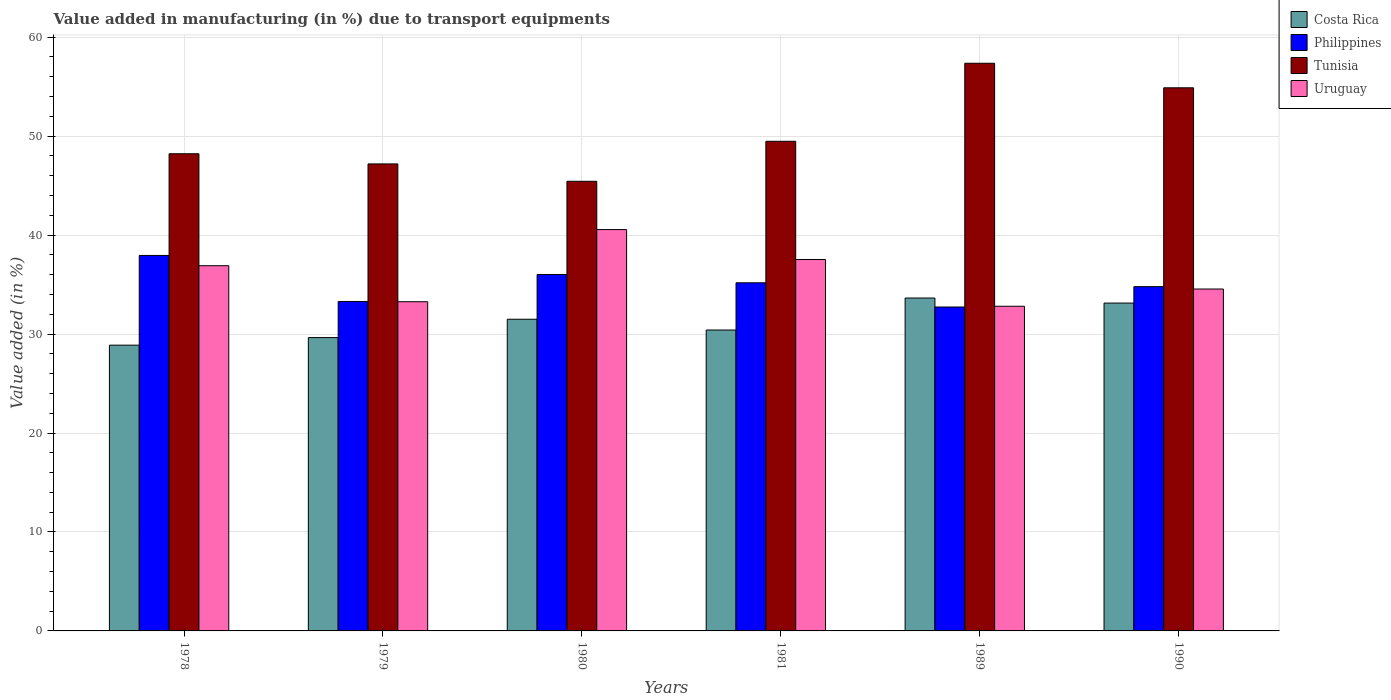How many bars are there on the 4th tick from the left?
Your answer should be compact. 4. How many bars are there on the 5th tick from the right?
Your answer should be compact. 4. What is the percentage of value added in manufacturing due to transport equipments in Philippines in 1981?
Your answer should be very brief. 35.18. Across all years, what is the maximum percentage of value added in manufacturing due to transport equipments in Uruguay?
Your answer should be compact. 40.56. Across all years, what is the minimum percentage of value added in manufacturing due to transport equipments in Uruguay?
Give a very brief answer. 32.81. In which year was the percentage of value added in manufacturing due to transport equipments in Uruguay minimum?
Keep it short and to the point. 1989. What is the total percentage of value added in manufacturing due to transport equipments in Uruguay in the graph?
Offer a terse response. 215.62. What is the difference between the percentage of value added in manufacturing due to transport equipments in Philippines in 1978 and that in 1990?
Keep it short and to the point. 3.15. What is the difference between the percentage of value added in manufacturing due to transport equipments in Philippines in 1981 and the percentage of value added in manufacturing due to transport equipments in Uruguay in 1989?
Keep it short and to the point. 2.37. What is the average percentage of value added in manufacturing due to transport equipments in Tunisia per year?
Keep it short and to the point. 50.43. In the year 1990, what is the difference between the percentage of value added in manufacturing due to transport equipments in Costa Rica and percentage of value added in manufacturing due to transport equipments in Tunisia?
Offer a terse response. -21.75. In how many years, is the percentage of value added in manufacturing due to transport equipments in Philippines greater than 6 %?
Make the answer very short. 6. What is the ratio of the percentage of value added in manufacturing due to transport equipments in Philippines in 1978 to that in 1981?
Your answer should be very brief. 1.08. Is the difference between the percentage of value added in manufacturing due to transport equipments in Costa Rica in 1980 and 1990 greater than the difference between the percentage of value added in manufacturing due to transport equipments in Tunisia in 1980 and 1990?
Provide a short and direct response. Yes. What is the difference between the highest and the second highest percentage of value added in manufacturing due to transport equipments in Uruguay?
Give a very brief answer. 3.03. What is the difference between the highest and the lowest percentage of value added in manufacturing due to transport equipments in Tunisia?
Make the answer very short. 11.93. In how many years, is the percentage of value added in manufacturing due to transport equipments in Uruguay greater than the average percentage of value added in manufacturing due to transport equipments in Uruguay taken over all years?
Keep it short and to the point. 3. Is the sum of the percentage of value added in manufacturing due to transport equipments in Costa Rica in 1981 and 1989 greater than the maximum percentage of value added in manufacturing due to transport equipments in Tunisia across all years?
Provide a short and direct response. Yes. What does the 3rd bar from the left in 1981 represents?
Give a very brief answer. Tunisia. Is it the case that in every year, the sum of the percentage of value added in manufacturing due to transport equipments in Philippines and percentage of value added in manufacturing due to transport equipments in Costa Rica is greater than the percentage of value added in manufacturing due to transport equipments in Tunisia?
Ensure brevity in your answer.  Yes. Are all the bars in the graph horizontal?
Offer a very short reply. No. What is the difference between two consecutive major ticks on the Y-axis?
Give a very brief answer. 10. Does the graph contain any zero values?
Offer a very short reply. No. Where does the legend appear in the graph?
Offer a terse response. Top right. How many legend labels are there?
Offer a terse response. 4. What is the title of the graph?
Keep it short and to the point. Value added in manufacturing (in %) due to transport equipments. Does "Bosnia and Herzegovina" appear as one of the legend labels in the graph?
Provide a short and direct response. No. What is the label or title of the X-axis?
Provide a short and direct response. Years. What is the label or title of the Y-axis?
Offer a terse response. Value added (in %). What is the Value added (in %) of Costa Rica in 1978?
Ensure brevity in your answer.  28.88. What is the Value added (in %) of Philippines in 1978?
Keep it short and to the point. 37.94. What is the Value added (in %) in Tunisia in 1978?
Provide a succinct answer. 48.22. What is the Value added (in %) in Uruguay in 1978?
Provide a short and direct response. 36.91. What is the Value added (in %) in Costa Rica in 1979?
Your answer should be compact. 29.64. What is the Value added (in %) of Philippines in 1979?
Provide a succinct answer. 33.29. What is the Value added (in %) in Tunisia in 1979?
Offer a very short reply. 47.19. What is the Value added (in %) of Uruguay in 1979?
Your answer should be compact. 33.27. What is the Value added (in %) of Costa Rica in 1980?
Give a very brief answer. 31.5. What is the Value added (in %) of Philippines in 1980?
Make the answer very short. 36.02. What is the Value added (in %) in Tunisia in 1980?
Ensure brevity in your answer.  45.44. What is the Value added (in %) of Uruguay in 1980?
Keep it short and to the point. 40.56. What is the Value added (in %) of Costa Rica in 1981?
Keep it short and to the point. 30.41. What is the Value added (in %) of Philippines in 1981?
Give a very brief answer. 35.18. What is the Value added (in %) in Tunisia in 1981?
Offer a very short reply. 49.48. What is the Value added (in %) of Uruguay in 1981?
Your answer should be compact. 37.53. What is the Value added (in %) in Costa Rica in 1989?
Ensure brevity in your answer.  33.64. What is the Value added (in %) in Philippines in 1989?
Your answer should be compact. 32.73. What is the Value added (in %) of Tunisia in 1989?
Make the answer very short. 57.36. What is the Value added (in %) of Uruguay in 1989?
Offer a terse response. 32.81. What is the Value added (in %) in Costa Rica in 1990?
Give a very brief answer. 33.13. What is the Value added (in %) of Philippines in 1990?
Provide a short and direct response. 34.79. What is the Value added (in %) in Tunisia in 1990?
Your answer should be very brief. 54.88. What is the Value added (in %) in Uruguay in 1990?
Your answer should be very brief. 34.55. Across all years, what is the maximum Value added (in %) in Costa Rica?
Your answer should be compact. 33.64. Across all years, what is the maximum Value added (in %) of Philippines?
Make the answer very short. 37.94. Across all years, what is the maximum Value added (in %) in Tunisia?
Offer a very short reply. 57.36. Across all years, what is the maximum Value added (in %) in Uruguay?
Give a very brief answer. 40.56. Across all years, what is the minimum Value added (in %) in Costa Rica?
Your response must be concise. 28.88. Across all years, what is the minimum Value added (in %) of Philippines?
Your response must be concise. 32.73. Across all years, what is the minimum Value added (in %) in Tunisia?
Offer a very short reply. 45.44. Across all years, what is the minimum Value added (in %) of Uruguay?
Your answer should be compact. 32.81. What is the total Value added (in %) of Costa Rica in the graph?
Ensure brevity in your answer.  187.19. What is the total Value added (in %) of Philippines in the graph?
Ensure brevity in your answer.  209.95. What is the total Value added (in %) of Tunisia in the graph?
Your response must be concise. 302.57. What is the total Value added (in %) in Uruguay in the graph?
Make the answer very short. 215.62. What is the difference between the Value added (in %) of Costa Rica in 1978 and that in 1979?
Give a very brief answer. -0.77. What is the difference between the Value added (in %) of Philippines in 1978 and that in 1979?
Offer a very short reply. 4.65. What is the difference between the Value added (in %) of Uruguay in 1978 and that in 1979?
Ensure brevity in your answer.  3.64. What is the difference between the Value added (in %) in Costa Rica in 1978 and that in 1980?
Your answer should be very brief. -2.62. What is the difference between the Value added (in %) of Philippines in 1978 and that in 1980?
Your response must be concise. 1.93. What is the difference between the Value added (in %) in Tunisia in 1978 and that in 1980?
Provide a short and direct response. 2.78. What is the difference between the Value added (in %) in Uruguay in 1978 and that in 1980?
Your response must be concise. -3.65. What is the difference between the Value added (in %) in Costa Rica in 1978 and that in 1981?
Offer a terse response. -1.53. What is the difference between the Value added (in %) in Philippines in 1978 and that in 1981?
Give a very brief answer. 2.76. What is the difference between the Value added (in %) in Tunisia in 1978 and that in 1981?
Keep it short and to the point. -1.26. What is the difference between the Value added (in %) of Uruguay in 1978 and that in 1981?
Ensure brevity in your answer.  -0.63. What is the difference between the Value added (in %) of Costa Rica in 1978 and that in 1989?
Give a very brief answer. -4.76. What is the difference between the Value added (in %) in Philippines in 1978 and that in 1989?
Your answer should be very brief. 5.21. What is the difference between the Value added (in %) in Tunisia in 1978 and that in 1989?
Ensure brevity in your answer.  -9.14. What is the difference between the Value added (in %) of Uruguay in 1978 and that in 1989?
Provide a short and direct response. 4.1. What is the difference between the Value added (in %) of Costa Rica in 1978 and that in 1990?
Provide a succinct answer. -4.25. What is the difference between the Value added (in %) of Philippines in 1978 and that in 1990?
Ensure brevity in your answer.  3.15. What is the difference between the Value added (in %) of Tunisia in 1978 and that in 1990?
Offer a very short reply. -6.66. What is the difference between the Value added (in %) of Uruguay in 1978 and that in 1990?
Provide a succinct answer. 2.36. What is the difference between the Value added (in %) in Costa Rica in 1979 and that in 1980?
Make the answer very short. -1.85. What is the difference between the Value added (in %) in Philippines in 1979 and that in 1980?
Provide a short and direct response. -2.73. What is the difference between the Value added (in %) in Tunisia in 1979 and that in 1980?
Your answer should be very brief. 1.76. What is the difference between the Value added (in %) in Uruguay in 1979 and that in 1980?
Your response must be concise. -7.29. What is the difference between the Value added (in %) of Costa Rica in 1979 and that in 1981?
Your answer should be compact. -0.76. What is the difference between the Value added (in %) in Philippines in 1979 and that in 1981?
Your answer should be compact. -1.89. What is the difference between the Value added (in %) of Tunisia in 1979 and that in 1981?
Provide a short and direct response. -2.29. What is the difference between the Value added (in %) of Uruguay in 1979 and that in 1981?
Offer a very short reply. -4.27. What is the difference between the Value added (in %) in Costa Rica in 1979 and that in 1989?
Make the answer very short. -4. What is the difference between the Value added (in %) of Philippines in 1979 and that in 1989?
Keep it short and to the point. 0.56. What is the difference between the Value added (in %) in Tunisia in 1979 and that in 1989?
Provide a short and direct response. -10.17. What is the difference between the Value added (in %) in Uruguay in 1979 and that in 1989?
Provide a short and direct response. 0.46. What is the difference between the Value added (in %) of Costa Rica in 1979 and that in 1990?
Provide a short and direct response. -3.49. What is the difference between the Value added (in %) in Philippines in 1979 and that in 1990?
Offer a terse response. -1.5. What is the difference between the Value added (in %) of Tunisia in 1979 and that in 1990?
Your answer should be very brief. -7.69. What is the difference between the Value added (in %) in Uruguay in 1979 and that in 1990?
Your answer should be very brief. -1.28. What is the difference between the Value added (in %) of Costa Rica in 1980 and that in 1981?
Ensure brevity in your answer.  1.09. What is the difference between the Value added (in %) in Philippines in 1980 and that in 1981?
Ensure brevity in your answer.  0.84. What is the difference between the Value added (in %) in Tunisia in 1980 and that in 1981?
Your answer should be compact. -4.04. What is the difference between the Value added (in %) in Uruguay in 1980 and that in 1981?
Make the answer very short. 3.03. What is the difference between the Value added (in %) in Costa Rica in 1980 and that in 1989?
Give a very brief answer. -2.14. What is the difference between the Value added (in %) in Philippines in 1980 and that in 1989?
Offer a very short reply. 3.28. What is the difference between the Value added (in %) of Tunisia in 1980 and that in 1989?
Keep it short and to the point. -11.93. What is the difference between the Value added (in %) in Uruguay in 1980 and that in 1989?
Make the answer very short. 7.75. What is the difference between the Value added (in %) of Costa Rica in 1980 and that in 1990?
Ensure brevity in your answer.  -1.63. What is the difference between the Value added (in %) in Philippines in 1980 and that in 1990?
Your answer should be compact. 1.23. What is the difference between the Value added (in %) of Tunisia in 1980 and that in 1990?
Provide a short and direct response. -9.45. What is the difference between the Value added (in %) of Uruguay in 1980 and that in 1990?
Keep it short and to the point. 6.01. What is the difference between the Value added (in %) of Costa Rica in 1981 and that in 1989?
Your answer should be compact. -3.23. What is the difference between the Value added (in %) of Philippines in 1981 and that in 1989?
Your answer should be very brief. 2.45. What is the difference between the Value added (in %) of Tunisia in 1981 and that in 1989?
Provide a succinct answer. -7.88. What is the difference between the Value added (in %) of Uruguay in 1981 and that in 1989?
Offer a terse response. 4.72. What is the difference between the Value added (in %) in Costa Rica in 1981 and that in 1990?
Provide a short and direct response. -2.72. What is the difference between the Value added (in %) of Philippines in 1981 and that in 1990?
Offer a very short reply. 0.39. What is the difference between the Value added (in %) in Tunisia in 1981 and that in 1990?
Your answer should be compact. -5.4. What is the difference between the Value added (in %) in Uruguay in 1981 and that in 1990?
Make the answer very short. 2.98. What is the difference between the Value added (in %) in Costa Rica in 1989 and that in 1990?
Provide a short and direct response. 0.51. What is the difference between the Value added (in %) of Philippines in 1989 and that in 1990?
Offer a terse response. -2.06. What is the difference between the Value added (in %) of Tunisia in 1989 and that in 1990?
Offer a terse response. 2.48. What is the difference between the Value added (in %) in Uruguay in 1989 and that in 1990?
Give a very brief answer. -1.74. What is the difference between the Value added (in %) of Costa Rica in 1978 and the Value added (in %) of Philippines in 1979?
Ensure brevity in your answer.  -4.41. What is the difference between the Value added (in %) in Costa Rica in 1978 and the Value added (in %) in Tunisia in 1979?
Provide a short and direct response. -18.32. What is the difference between the Value added (in %) of Costa Rica in 1978 and the Value added (in %) of Uruguay in 1979?
Give a very brief answer. -4.39. What is the difference between the Value added (in %) in Philippines in 1978 and the Value added (in %) in Tunisia in 1979?
Keep it short and to the point. -9.25. What is the difference between the Value added (in %) in Philippines in 1978 and the Value added (in %) in Uruguay in 1979?
Your answer should be very brief. 4.68. What is the difference between the Value added (in %) in Tunisia in 1978 and the Value added (in %) in Uruguay in 1979?
Provide a short and direct response. 14.95. What is the difference between the Value added (in %) of Costa Rica in 1978 and the Value added (in %) of Philippines in 1980?
Offer a terse response. -7.14. What is the difference between the Value added (in %) in Costa Rica in 1978 and the Value added (in %) in Tunisia in 1980?
Your response must be concise. -16.56. What is the difference between the Value added (in %) in Costa Rica in 1978 and the Value added (in %) in Uruguay in 1980?
Keep it short and to the point. -11.68. What is the difference between the Value added (in %) in Philippines in 1978 and the Value added (in %) in Tunisia in 1980?
Ensure brevity in your answer.  -7.49. What is the difference between the Value added (in %) in Philippines in 1978 and the Value added (in %) in Uruguay in 1980?
Ensure brevity in your answer.  -2.61. What is the difference between the Value added (in %) of Tunisia in 1978 and the Value added (in %) of Uruguay in 1980?
Make the answer very short. 7.66. What is the difference between the Value added (in %) in Costa Rica in 1978 and the Value added (in %) in Philippines in 1981?
Your answer should be very brief. -6.3. What is the difference between the Value added (in %) of Costa Rica in 1978 and the Value added (in %) of Tunisia in 1981?
Offer a very short reply. -20.6. What is the difference between the Value added (in %) in Costa Rica in 1978 and the Value added (in %) in Uruguay in 1981?
Ensure brevity in your answer.  -8.65. What is the difference between the Value added (in %) in Philippines in 1978 and the Value added (in %) in Tunisia in 1981?
Provide a succinct answer. -11.54. What is the difference between the Value added (in %) of Philippines in 1978 and the Value added (in %) of Uruguay in 1981?
Offer a very short reply. 0.41. What is the difference between the Value added (in %) in Tunisia in 1978 and the Value added (in %) in Uruguay in 1981?
Keep it short and to the point. 10.69. What is the difference between the Value added (in %) of Costa Rica in 1978 and the Value added (in %) of Philippines in 1989?
Provide a short and direct response. -3.86. What is the difference between the Value added (in %) of Costa Rica in 1978 and the Value added (in %) of Tunisia in 1989?
Provide a short and direct response. -28.49. What is the difference between the Value added (in %) of Costa Rica in 1978 and the Value added (in %) of Uruguay in 1989?
Give a very brief answer. -3.93. What is the difference between the Value added (in %) of Philippines in 1978 and the Value added (in %) of Tunisia in 1989?
Offer a very short reply. -19.42. What is the difference between the Value added (in %) of Philippines in 1978 and the Value added (in %) of Uruguay in 1989?
Keep it short and to the point. 5.14. What is the difference between the Value added (in %) of Tunisia in 1978 and the Value added (in %) of Uruguay in 1989?
Ensure brevity in your answer.  15.41. What is the difference between the Value added (in %) in Costa Rica in 1978 and the Value added (in %) in Philippines in 1990?
Your answer should be compact. -5.91. What is the difference between the Value added (in %) of Costa Rica in 1978 and the Value added (in %) of Tunisia in 1990?
Your response must be concise. -26.01. What is the difference between the Value added (in %) of Costa Rica in 1978 and the Value added (in %) of Uruguay in 1990?
Your answer should be very brief. -5.67. What is the difference between the Value added (in %) of Philippines in 1978 and the Value added (in %) of Tunisia in 1990?
Provide a short and direct response. -16.94. What is the difference between the Value added (in %) of Philippines in 1978 and the Value added (in %) of Uruguay in 1990?
Ensure brevity in your answer.  3.39. What is the difference between the Value added (in %) in Tunisia in 1978 and the Value added (in %) in Uruguay in 1990?
Make the answer very short. 13.67. What is the difference between the Value added (in %) in Costa Rica in 1979 and the Value added (in %) in Philippines in 1980?
Offer a very short reply. -6.37. What is the difference between the Value added (in %) in Costa Rica in 1979 and the Value added (in %) in Tunisia in 1980?
Your answer should be very brief. -15.79. What is the difference between the Value added (in %) in Costa Rica in 1979 and the Value added (in %) in Uruguay in 1980?
Your answer should be very brief. -10.92. What is the difference between the Value added (in %) of Philippines in 1979 and the Value added (in %) of Tunisia in 1980?
Your response must be concise. -12.15. What is the difference between the Value added (in %) of Philippines in 1979 and the Value added (in %) of Uruguay in 1980?
Your answer should be compact. -7.27. What is the difference between the Value added (in %) in Tunisia in 1979 and the Value added (in %) in Uruguay in 1980?
Ensure brevity in your answer.  6.63. What is the difference between the Value added (in %) in Costa Rica in 1979 and the Value added (in %) in Philippines in 1981?
Ensure brevity in your answer.  -5.54. What is the difference between the Value added (in %) in Costa Rica in 1979 and the Value added (in %) in Tunisia in 1981?
Your answer should be very brief. -19.84. What is the difference between the Value added (in %) of Costa Rica in 1979 and the Value added (in %) of Uruguay in 1981?
Provide a short and direct response. -7.89. What is the difference between the Value added (in %) of Philippines in 1979 and the Value added (in %) of Tunisia in 1981?
Provide a short and direct response. -16.19. What is the difference between the Value added (in %) of Philippines in 1979 and the Value added (in %) of Uruguay in 1981?
Ensure brevity in your answer.  -4.24. What is the difference between the Value added (in %) in Tunisia in 1979 and the Value added (in %) in Uruguay in 1981?
Offer a very short reply. 9.66. What is the difference between the Value added (in %) of Costa Rica in 1979 and the Value added (in %) of Philippines in 1989?
Offer a very short reply. -3.09. What is the difference between the Value added (in %) of Costa Rica in 1979 and the Value added (in %) of Tunisia in 1989?
Make the answer very short. -27.72. What is the difference between the Value added (in %) in Costa Rica in 1979 and the Value added (in %) in Uruguay in 1989?
Your response must be concise. -3.17. What is the difference between the Value added (in %) of Philippines in 1979 and the Value added (in %) of Tunisia in 1989?
Your response must be concise. -24.07. What is the difference between the Value added (in %) in Philippines in 1979 and the Value added (in %) in Uruguay in 1989?
Offer a very short reply. 0.48. What is the difference between the Value added (in %) in Tunisia in 1979 and the Value added (in %) in Uruguay in 1989?
Provide a short and direct response. 14.38. What is the difference between the Value added (in %) of Costa Rica in 1979 and the Value added (in %) of Philippines in 1990?
Your response must be concise. -5.15. What is the difference between the Value added (in %) of Costa Rica in 1979 and the Value added (in %) of Tunisia in 1990?
Your answer should be very brief. -25.24. What is the difference between the Value added (in %) of Costa Rica in 1979 and the Value added (in %) of Uruguay in 1990?
Provide a short and direct response. -4.91. What is the difference between the Value added (in %) of Philippines in 1979 and the Value added (in %) of Tunisia in 1990?
Provide a succinct answer. -21.59. What is the difference between the Value added (in %) of Philippines in 1979 and the Value added (in %) of Uruguay in 1990?
Provide a succinct answer. -1.26. What is the difference between the Value added (in %) in Tunisia in 1979 and the Value added (in %) in Uruguay in 1990?
Offer a terse response. 12.64. What is the difference between the Value added (in %) in Costa Rica in 1980 and the Value added (in %) in Philippines in 1981?
Provide a short and direct response. -3.68. What is the difference between the Value added (in %) of Costa Rica in 1980 and the Value added (in %) of Tunisia in 1981?
Your answer should be very brief. -17.98. What is the difference between the Value added (in %) in Costa Rica in 1980 and the Value added (in %) in Uruguay in 1981?
Offer a very short reply. -6.04. What is the difference between the Value added (in %) of Philippines in 1980 and the Value added (in %) of Tunisia in 1981?
Ensure brevity in your answer.  -13.46. What is the difference between the Value added (in %) of Philippines in 1980 and the Value added (in %) of Uruguay in 1981?
Your answer should be very brief. -1.52. What is the difference between the Value added (in %) of Tunisia in 1980 and the Value added (in %) of Uruguay in 1981?
Your answer should be compact. 7.9. What is the difference between the Value added (in %) of Costa Rica in 1980 and the Value added (in %) of Philippines in 1989?
Provide a succinct answer. -1.24. What is the difference between the Value added (in %) of Costa Rica in 1980 and the Value added (in %) of Tunisia in 1989?
Keep it short and to the point. -25.87. What is the difference between the Value added (in %) in Costa Rica in 1980 and the Value added (in %) in Uruguay in 1989?
Provide a succinct answer. -1.31. What is the difference between the Value added (in %) in Philippines in 1980 and the Value added (in %) in Tunisia in 1989?
Your response must be concise. -21.35. What is the difference between the Value added (in %) of Philippines in 1980 and the Value added (in %) of Uruguay in 1989?
Your answer should be very brief. 3.21. What is the difference between the Value added (in %) of Tunisia in 1980 and the Value added (in %) of Uruguay in 1989?
Your answer should be very brief. 12.63. What is the difference between the Value added (in %) in Costa Rica in 1980 and the Value added (in %) in Philippines in 1990?
Your response must be concise. -3.29. What is the difference between the Value added (in %) of Costa Rica in 1980 and the Value added (in %) of Tunisia in 1990?
Offer a terse response. -23.39. What is the difference between the Value added (in %) in Costa Rica in 1980 and the Value added (in %) in Uruguay in 1990?
Offer a terse response. -3.05. What is the difference between the Value added (in %) in Philippines in 1980 and the Value added (in %) in Tunisia in 1990?
Your answer should be very brief. -18.87. What is the difference between the Value added (in %) in Philippines in 1980 and the Value added (in %) in Uruguay in 1990?
Make the answer very short. 1.47. What is the difference between the Value added (in %) in Tunisia in 1980 and the Value added (in %) in Uruguay in 1990?
Your response must be concise. 10.89. What is the difference between the Value added (in %) in Costa Rica in 1981 and the Value added (in %) in Philippines in 1989?
Your answer should be very brief. -2.33. What is the difference between the Value added (in %) of Costa Rica in 1981 and the Value added (in %) of Tunisia in 1989?
Ensure brevity in your answer.  -26.96. What is the difference between the Value added (in %) in Costa Rica in 1981 and the Value added (in %) in Uruguay in 1989?
Ensure brevity in your answer.  -2.4. What is the difference between the Value added (in %) in Philippines in 1981 and the Value added (in %) in Tunisia in 1989?
Provide a short and direct response. -22.18. What is the difference between the Value added (in %) of Philippines in 1981 and the Value added (in %) of Uruguay in 1989?
Make the answer very short. 2.37. What is the difference between the Value added (in %) of Tunisia in 1981 and the Value added (in %) of Uruguay in 1989?
Provide a succinct answer. 16.67. What is the difference between the Value added (in %) in Costa Rica in 1981 and the Value added (in %) in Philippines in 1990?
Offer a terse response. -4.38. What is the difference between the Value added (in %) of Costa Rica in 1981 and the Value added (in %) of Tunisia in 1990?
Your answer should be compact. -24.48. What is the difference between the Value added (in %) of Costa Rica in 1981 and the Value added (in %) of Uruguay in 1990?
Offer a very short reply. -4.14. What is the difference between the Value added (in %) in Philippines in 1981 and the Value added (in %) in Tunisia in 1990?
Provide a succinct answer. -19.7. What is the difference between the Value added (in %) of Philippines in 1981 and the Value added (in %) of Uruguay in 1990?
Provide a succinct answer. 0.63. What is the difference between the Value added (in %) in Tunisia in 1981 and the Value added (in %) in Uruguay in 1990?
Provide a short and direct response. 14.93. What is the difference between the Value added (in %) of Costa Rica in 1989 and the Value added (in %) of Philippines in 1990?
Your response must be concise. -1.15. What is the difference between the Value added (in %) of Costa Rica in 1989 and the Value added (in %) of Tunisia in 1990?
Give a very brief answer. -21.24. What is the difference between the Value added (in %) of Costa Rica in 1989 and the Value added (in %) of Uruguay in 1990?
Ensure brevity in your answer.  -0.91. What is the difference between the Value added (in %) in Philippines in 1989 and the Value added (in %) in Tunisia in 1990?
Your response must be concise. -22.15. What is the difference between the Value added (in %) of Philippines in 1989 and the Value added (in %) of Uruguay in 1990?
Offer a very short reply. -1.82. What is the difference between the Value added (in %) of Tunisia in 1989 and the Value added (in %) of Uruguay in 1990?
Keep it short and to the point. 22.81. What is the average Value added (in %) of Costa Rica per year?
Keep it short and to the point. 31.2. What is the average Value added (in %) in Philippines per year?
Your answer should be compact. 34.99. What is the average Value added (in %) of Tunisia per year?
Your response must be concise. 50.43. What is the average Value added (in %) of Uruguay per year?
Offer a very short reply. 35.94. In the year 1978, what is the difference between the Value added (in %) in Costa Rica and Value added (in %) in Philippines?
Give a very brief answer. -9.07. In the year 1978, what is the difference between the Value added (in %) of Costa Rica and Value added (in %) of Tunisia?
Offer a terse response. -19.34. In the year 1978, what is the difference between the Value added (in %) of Costa Rica and Value added (in %) of Uruguay?
Offer a very short reply. -8.03. In the year 1978, what is the difference between the Value added (in %) of Philippines and Value added (in %) of Tunisia?
Your answer should be compact. -10.28. In the year 1978, what is the difference between the Value added (in %) of Philippines and Value added (in %) of Uruguay?
Make the answer very short. 1.04. In the year 1978, what is the difference between the Value added (in %) of Tunisia and Value added (in %) of Uruguay?
Keep it short and to the point. 11.31. In the year 1979, what is the difference between the Value added (in %) of Costa Rica and Value added (in %) of Philippines?
Provide a short and direct response. -3.65. In the year 1979, what is the difference between the Value added (in %) in Costa Rica and Value added (in %) in Tunisia?
Offer a very short reply. -17.55. In the year 1979, what is the difference between the Value added (in %) in Costa Rica and Value added (in %) in Uruguay?
Give a very brief answer. -3.62. In the year 1979, what is the difference between the Value added (in %) of Philippines and Value added (in %) of Tunisia?
Give a very brief answer. -13.9. In the year 1979, what is the difference between the Value added (in %) in Philippines and Value added (in %) in Uruguay?
Your answer should be compact. 0.03. In the year 1979, what is the difference between the Value added (in %) of Tunisia and Value added (in %) of Uruguay?
Your response must be concise. 13.93. In the year 1980, what is the difference between the Value added (in %) in Costa Rica and Value added (in %) in Philippines?
Your answer should be compact. -4.52. In the year 1980, what is the difference between the Value added (in %) of Costa Rica and Value added (in %) of Tunisia?
Keep it short and to the point. -13.94. In the year 1980, what is the difference between the Value added (in %) of Costa Rica and Value added (in %) of Uruguay?
Your response must be concise. -9.06. In the year 1980, what is the difference between the Value added (in %) in Philippines and Value added (in %) in Tunisia?
Keep it short and to the point. -9.42. In the year 1980, what is the difference between the Value added (in %) of Philippines and Value added (in %) of Uruguay?
Make the answer very short. -4.54. In the year 1980, what is the difference between the Value added (in %) of Tunisia and Value added (in %) of Uruguay?
Ensure brevity in your answer.  4.88. In the year 1981, what is the difference between the Value added (in %) of Costa Rica and Value added (in %) of Philippines?
Keep it short and to the point. -4.77. In the year 1981, what is the difference between the Value added (in %) of Costa Rica and Value added (in %) of Tunisia?
Your answer should be very brief. -19.07. In the year 1981, what is the difference between the Value added (in %) of Costa Rica and Value added (in %) of Uruguay?
Keep it short and to the point. -7.13. In the year 1981, what is the difference between the Value added (in %) of Philippines and Value added (in %) of Tunisia?
Your answer should be very brief. -14.3. In the year 1981, what is the difference between the Value added (in %) of Philippines and Value added (in %) of Uruguay?
Give a very brief answer. -2.35. In the year 1981, what is the difference between the Value added (in %) of Tunisia and Value added (in %) of Uruguay?
Provide a succinct answer. 11.95. In the year 1989, what is the difference between the Value added (in %) of Costa Rica and Value added (in %) of Philippines?
Provide a short and direct response. 0.91. In the year 1989, what is the difference between the Value added (in %) of Costa Rica and Value added (in %) of Tunisia?
Your answer should be compact. -23.72. In the year 1989, what is the difference between the Value added (in %) of Costa Rica and Value added (in %) of Uruguay?
Keep it short and to the point. 0.83. In the year 1989, what is the difference between the Value added (in %) of Philippines and Value added (in %) of Tunisia?
Offer a terse response. -24.63. In the year 1989, what is the difference between the Value added (in %) in Philippines and Value added (in %) in Uruguay?
Offer a terse response. -0.08. In the year 1989, what is the difference between the Value added (in %) of Tunisia and Value added (in %) of Uruguay?
Your response must be concise. 24.56. In the year 1990, what is the difference between the Value added (in %) in Costa Rica and Value added (in %) in Philippines?
Offer a very short reply. -1.66. In the year 1990, what is the difference between the Value added (in %) in Costa Rica and Value added (in %) in Tunisia?
Provide a short and direct response. -21.75. In the year 1990, what is the difference between the Value added (in %) of Costa Rica and Value added (in %) of Uruguay?
Ensure brevity in your answer.  -1.42. In the year 1990, what is the difference between the Value added (in %) of Philippines and Value added (in %) of Tunisia?
Your response must be concise. -20.09. In the year 1990, what is the difference between the Value added (in %) in Philippines and Value added (in %) in Uruguay?
Make the answer very short. 0.24. In the year 1990, what is the difference between the Value added (in %) of Tunisia and Value added (in %) of Uruguay?
Keep it short and to the point. 20.33. What is the ratio of the Value added (in %) of Costa Rica in 1978 to that in 1979?
Offer a very short reply. 0.97. What is the ratio of the Value added (in %) in Philippines in 1978 to that in 1979?
Your answer should be very brief. 1.14. What is the ratio of the Value added (in %) in Tunisia in 1978 to that in 1979?
Offer a terse response. 1.02. What is the ratio of the Value added (in %) of Uruguay in 1978 to that in 1979?
Provide a succinct answer. 1.11. What is the ratio of the Value added (in %) of Costa Rica in 1978 to that in 1980?
Offer a very short reply. 0.92. What is the ratio of the Value added (in %) of Philippines in 1978 to that in 1980?
Ensure brevity in your answer.  1.05. What is the ratio of the Value added (in %) in Tunisia in 1978 to that in 1980?
Your response must be concise. 1.06. What is the ratio of the Value added (in %) of Uruguay in 1978 to that in 1980?
Give a very brief answer. 0.91. What is the ratio of the Value added (in %) of Costa Rica in 1978 to that in 1981?
Ensure brevity in your answer.  0.95. What is the ratio of the Value added (in %) in Philippines in 1978 to that in 1981?
Provide a short and direct response. 1.08. What is the ratio of the Value added (in %) of Tunisia in 1978 to that in 1981?
Offer a terse response. 0.97. What is the ratio of the Value added (in %) of Uruguay in 1978 to that in 1981?
Provide a succinct answer. 0.98. What is the ratio of the Value added (in %) in Costa Rica in 1978 to that in 1989?
Provide a short and direct response. 0.86. What is the ratio of the Value added (in %) of Philippines in 1978 to that in 1989?
Provide a succinct answer. 1.16. What is the ratio of the Value added (in %) in Tunisia in 1978 to that in 1989?
Give a very brief answer. 0.84. What is the ratio of the Value added (in %) in Uruguay in 1978 to that in 1989?
Your answer should be compact. 1.12. What is the ratio of the Value added (in %) in Costa Rica in 1978 to that in 1990?
Offer a very short reply. 0.87. What is the ratio of the Value added (in %) in Philippines in 1978 to that in 1990?
Your response must be concise. 1.09. What is the ratio of the Value added (in %) of Tunisia in 1978 to that in 1990?
Ensure brevity in your answer.  0.88. What is the ratio of the Value added (in %) in Uruguay in 1978 to that in 1990?
Provide a short and direct response. 1.07. What is the ratio of the Value added (in %) of Costa Rica in 1979 to that in 1980?
Provide a succinct answer. 0.94. What is the ratio of the Value added (in %) in Philippines in 1979 to that in 1980?
Keep it short and to the point. 0.92. What is the ratio of the Value added (in %) of Tunisia in 1979 to that in 1980?
Ensure brevity in your answer.  1.04. What is the ratio of the Value added (in %) of Uruguay in 1979 to that in 1980?
Offer a terse response. 0.82. What is the ratio of the Value added (in %) of Costa Rica in 1979 to that in 1981?
Provide a succinct answer. 0.97. What is the ratio of the Value added (in %) in Philippines in 1979 to that in 1981?
Provide a short and direct response. 0.95. What is the ratio of the Value added (in %) of Tunisia in 1979 to that in 1981?
Your response must be concise. 0.95. What is the ratio of the Value added (in %) in Uruguay in 1979 to that in 1981?
Your answer should be very brief. 0.89. What is the ratio of the Value added (in %) in Costa Rica in 1979 to that in 1989?
Make the answer very short. 0.88. What is the ratio of the Value added (in %) in Philippines in 1979 to that in 1989?
Your answer should be very brief. 1.02. What is the ratio of the Value added (in %) of Tunisia in 1979 to that in 1989?
Your answer should be compact. 0.82. What is the ratio of the Value added (in %) in Costa Rica in 1979 to that in 1990?
Give a very brief answer. 0.89. What is the ratio of the Value added (in %) in Philippines in 1979 to that in 1990?
Make the answer very short. 0.96. What is the ratio of the Value added (in %) of Tunisia in 1979 to that in 1990?
Make the answer very short. 0.86. What is the ratio of the Value added (in %) of Uruguay in 1979 to that in 1990?
Keep it short and to the point. 0.96. What is the ratio of the Value added (in %) in Costa Rica in 1980 to that in 1981?
Ensure brevity in your answer.  1.04. What is the ratio of the Value added (in %) in Philippines in 1980 to that in 1981?
Give a very brief answer. 1.02. What is the ratio of the Value added (in %) in Tunisia in 1980 to that in 1981?
Your answer should be very brief. 0.92. What is the ratio of the Value added (in %) of Uruguay in 1980 to that in 1981?
Give a very brief answer. 1.08. What is the ratio of the Value added (in %) of Costa Rica in 1980 to that in 1989?
Ensure brevity in your answer.  0.94. What is the ratio of the Value added (in %) in Philippines in 1980 to that in 1989?
Provide a succinct answer. 1.1. What is the ratio of the Value added (in %) in Tunisia in 1980 to that in 1989?
Your answer should be compact. 0.79. What is the ratio of the Value added (in %) in Uruguay in 1980 to that in 1989?
Offer a terse response. 1.24. What is the ratio of the Value added (in %) in Costa Rica in 1980 to that in 1990?
Your answer should be compact. 0.95. What is the ratio of the Value added (in %) in Philippines in 1980 to that in 1990?
Make the answer very short. 1.04. What is the ratio of the Value added (in %) of Tunisia in 1980 to that in 1990?
Keep it short and to the point. 0.83. What is the ratio of the Value added (in %) in Uruguay in 1980 to that in 1990?
Keep it short and to the point. 1.17. What is the ratio of the Value added (in %) of Costa Rica in 1981 to that in 1989?
Give a very brief answer. 0.9. What is the ratio of the Value added (in %) in Philippines in 1981 to that in 1989?
Your answer should be very brief. 1.07. What is the ratio of the Value added (in %) in Tunisia in 1981 to that in 1989?
Give a very brief answer. 0.86. What is the ratio of the Value added (in %) in Uruguay in 1981 to that in 1989?
Give a very brief answer. 1.14. What is the ratio of the Value added (in %) in Costa Rica in 1981 to that in 1990?
Ensure brevity in your answer.  0.92. What is the ratio of the Value added (in %) in Philippines in 1981 to that in 1990?
Make the answer very short. 1.01. What is the ratio of the Value added (in %) in Tunisia in 1981 to that in 1990?
Your answer should be very brief. 0.9. What is the ratio of the Value added (in %) in Uruguay in 1981 to that in 1990?
Offer a terse response. 1.09. What is the ratio of the Value added (in %) of Costa Rica in 1989 to that in 1990?
Offer a terse response. 1.02. What is the ratio of the Value added (in %) of Philippines in 1989 to that in 1990?
Your response must be concise. 0.94. What is the ratio of the Value added (in %) of Tunisia in 1989 to that in 1990?
Your response must be concise. 1.05. What is the ratio of the Value added (in %) of Uruguay in 1989 to that in 1990?
Your answer should be very brief. 0.95. What is the difference between the highest and the second highest Value added (in %) in Costa Rica?
Offer a very short reply. 0.51. What is the difference between the highest and the second highest Value added (in %) in Philippines?
Give a very brief answer. 1.93. What is the difference between the highest and the second highest Value added (in %) in Tunisia?
Provide a short and direct response. 2.48. What is the difference between the highest and the second highest Value added (in %) in Uruguay?
Offer a very short reply. 3.03. What is the difference between the highest and the lowest Value added (in %) of Costa Rica?
Make the answer very short. 4.76. What is the difference between the highest and the lowest Value added (in %) in Philippines?
Offer a very short reply. 5.21. What is the difference between the highest and the lowest Value added (in %) of Tunisia?
Offer a very short reply. 11.93. What is the difference between the highest and the lowest Value added (in %) of Uruguay?
Your answer should be compact. 7.75. 